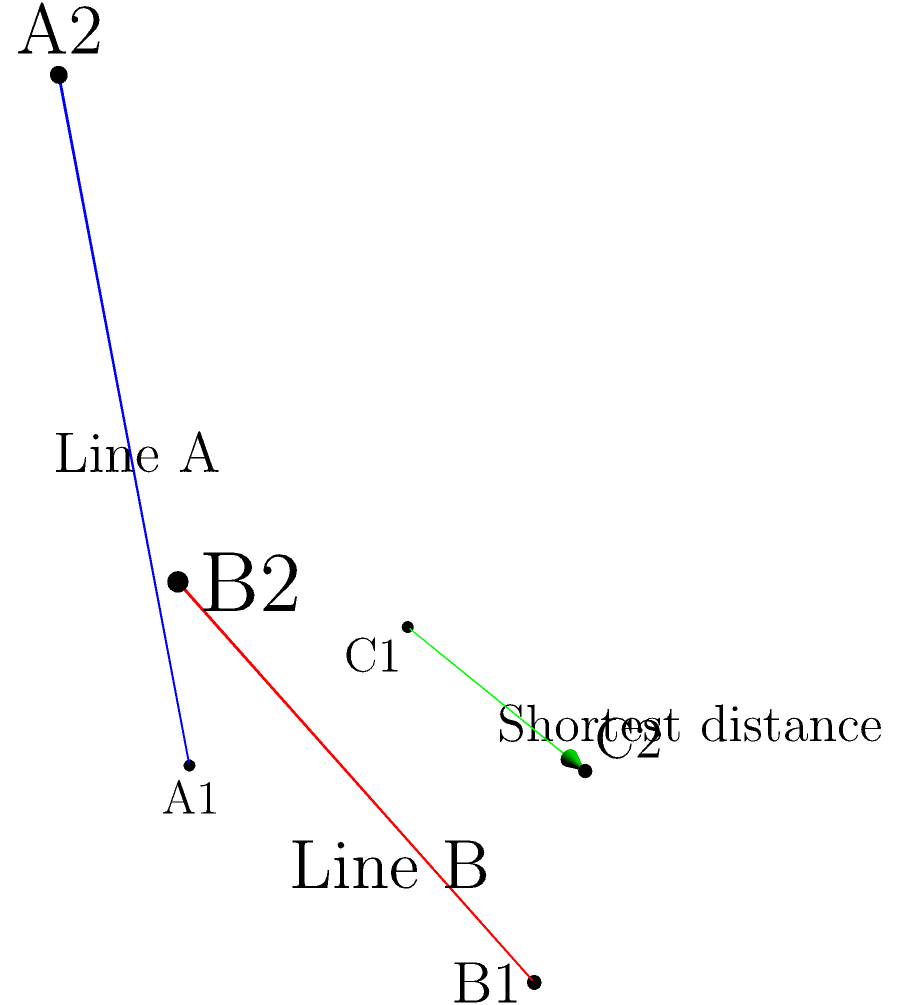As a freelance writer setting up a blog with specific post types for different topics, you want to include a challenging geometry problem to engage your readers. Consider two skew lines in 3D space:

Line A: Passing through points $(0,0,0)$ and $(2,1,3)$
Line B: Passing through points $(1,2,0)$ and $(3,2,2)$

Calculate the shortest distance between these two skew lines. Round your answer to two decimal places. To find the shortest distance between two skew lines, we'll follow these steps:

1) First, let's define the direction vectors of the lines:
   $\vec{a} = (2,1,3) - (0,0,0) = (2,1,3)$
   $\vec{b} = (3,2,2) - (1,2,0) = (2,0,2)$

2) The vector perpendicular to both lines is their cross product:
   $\vec{n} = \vec{a} \times \vec{b} = (1\cdot2 - 3\cdot0, 3\cdot2 - 2\cdot2, 2\cdot0 - 1\cdot2) = (2,-2,-2)$

3) Now, we need a vector connecting any point on line A to any point on line B:
   $\vec{c} = (1,2,0) - (0,0,0) = (1,2,0)$

4) The shortest distance is the projection of $\vec{c}$ onto the unit vector in the direction of $\vec{n}$:

   $d = \frac{|\vec{c} \cdot \vec{n}|}{|\vec{n}|}$

5) Calculate the dot product $\vec{c} \cdot \vec{n}$:
   $(1,2,0) \cdot (2,-2,-2) = 2 - 4 + 0 = -2$

6) Calculate the magnitude of $\vec{n}$:
   $|\vec{n}| = \sqrt{2^2 + (-2)^2 + (-2)^2} = \sqrt{12} = 2\sqrt{3}$

7) Now we can calculate the distance:
   $d = \frac{|-2|}{2\sqrt{3}} = \frac{1}{\sqrt{3}} \approx 0.5774$

Rounding to two decimal places, we get 0.58.
Answer: 0.58 units 